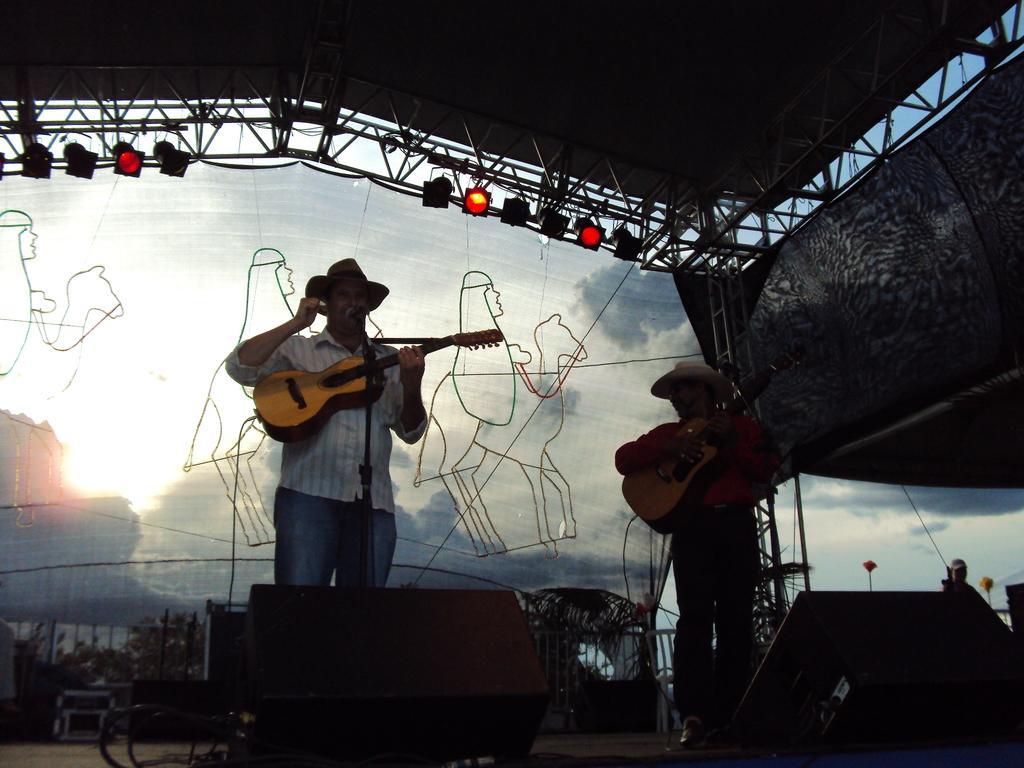Could you give a brief overview of what you see in this image? In this image i can see there are two men who are holding guitar in front of a microphone. 